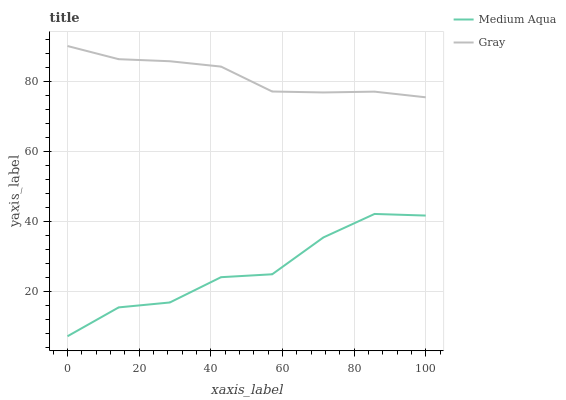Does Medium Aqua have the minimum area under the curve?
Answer yes or no. Yes. Does Gray have the maximum area under the curve?
Answer yes or no. Yes. Does Medium Aqua have the maximum area under the curve?
Answer yes or no. No. Is Gray the smoothest?
Answer yes or no. Yes. Is Medium Aqua the roughest?
Answer yes or no. Yes. Is Medium Aqua the smoothest?
Answer yes or no. No. Does Gray have the highest value?
Answer yes or no. Yes. Does Medium Aqua have the highest value?
Answer yes or no. No. Is Medium Aqua less than Gray?
Answer yes or no. Yes. Is Gray greater than Medium Aqua?
Answer yes or no. Yes. Does Medium Aqua intersect Gray?
Answer yes or no. No. 